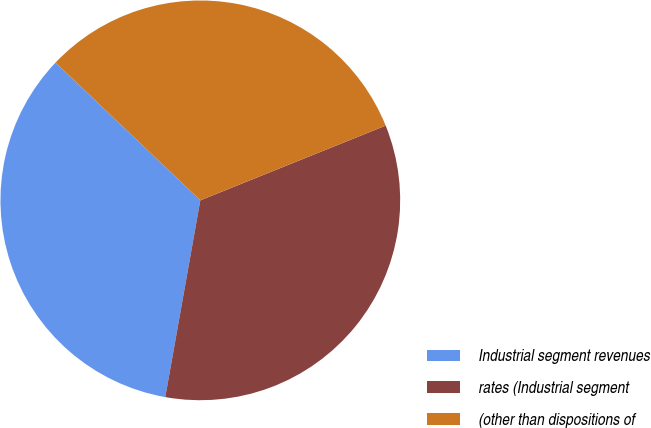<chart> <loc_0><loc_0><loc_500><loc_500><pie_chart><fcel>Industrial segment revenues<fcel>rates (Industrial segment<fcel>(other than dispositions of<nl><fcel>34.3%<fcel>33.9%<fcel>31.79%<nl></chart> 